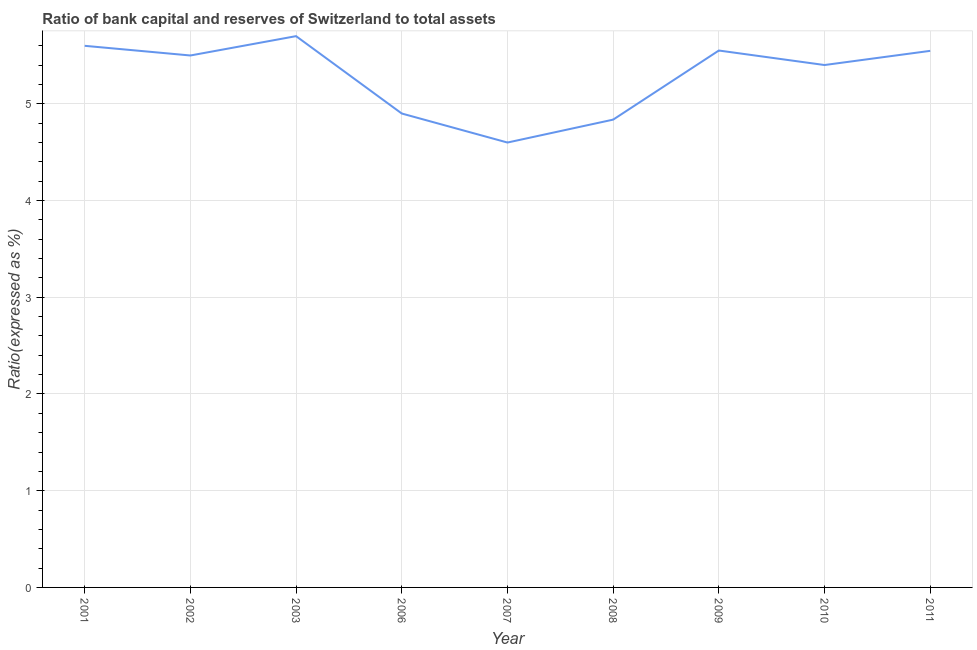Across all years, what is the maximum bank capital to assets ratio?
Provide a short and direct response. 5.7. In which year was the bank capital to assets ratio minimum?
Provide a short and direct response. 2007. What is the sum of the bank capital to assets ratio?
Provide a short and direct response. 47.64. What is the difference between the bank capital to assets ratio in 2002 and 2010?
Your response must be concise. 0.1. What is the average bank capital to assets ratio per year?
Your response must be concise. 5.29. What is the median bank capital to assets ratio?
Provide a short and direct response. 5.5. What is the ratio of the bank capital to assets ratio in 2002 to that in 2011?
Your response must be concise. 0.99. Is the bank capital to assets ratio in 2002 less than that in 2006?
Ensure brevity in your answer.  No. What is the difference between the highest and the second highest bank capital to assets ratio?
Give a very brief answer. 0.1. What is the difference between the highest and the lowest bank capital to assets ratio?
Ensure brevity in your answer.  1.1. Does the bank capital to assets ratio monotonically increase over the years?
Your answer should be compact. No. How many lines are there?
Keep it short and to the point. 1. Does the graph contain grids?
Ensure brevity in your answer.  Yes. What is the title of the graph?
Your response must be concise. Ratio of bank capital and reserves of Switzerland to total assets. What is the label or title of the X-axis?
Give a very brief answer. Year. What is the label or title of the Y-axis?
Provide a short and direct response. Ratio(expressed as %). What is the Ratio(expressed as %) in 2001?
Offer a very short reply. 5.6. What is the Ratio(expressed as %) of 2002?
Keep it short and to the point. 5.5. What is the Ratio(expressed as %) in 2003?
Give a very brief answer. 5.7. What is the Ratio(expressed as %) in 2006?
Ensure brevity in your answer.  4.9. What is the Ratio(expressed as %) of 2007?
Keep it short and to the point. 4.6. What is the Ratio(expressed as %) in 2008?
Provide a succinct answer. 4.84. What is the Ratio(expressed as %) of 2009?
Your response must be concise. 5.55. What is the Ratio(expressed as %) of 2010?
Provide a succinct answer. 5.4. What is the Ratio(expressed as %) in 2011?
Offer a very short reply. 5.55. What is the difference between the Ratio(expressed as %) in 2001 and 2002?
Your answer should be very brief. 0.1. What is the difference between the Ratio(expressed as %) in 2001 and 2008?
Your answer should be compact. 0.76. What is the difference between the Ratio(expressed as %) in 2001 and 2009?
Your answer should be compact. 0.05. What is the difference between the Ratio(expressed as %) in 2001 and 2010?
Make the answer very short. 0.2. What is the difference between the Ratio(expressed as %) in 2001 and 2011?
Make the answer very short. 0.05. What is the difference between the Ratio(expressed as %) in 2002 and 2003?
Your answer should be compact. -0.2. What is the difference between the Ratio(expressed as %) in 2002 and 2006?
Provide a succinct answer. 0.6. What is the difference between the Ratio(expressed as %) in 2002 and 2007?
Provide a short and direct response. 0.9. What is the difference between the Ratio(expressed as %) in 2002 and 2008?
Give a very brief answer. 0.66. What is the difference between the Ratio(expressed as %) in 2002 and 2009?
Offer a very short reply. -0.05. What is the difference between the Ratio(expressed as %) in 2002 and 2010?
Provide a short and direct response. 0.1. What is the difference between the Ratio(expressed as %) in 2002 and 2011?
Your answer should be compact. -0.05. What is the difference between the Ratio(expressed as %) in 2003 and 2006?
Your answer should be compact. 0.8. What is the difference between the Ratio(expressed as %) in 2003 and 2008?
Your response must be concise. 0.86. What is the difference between the Ratio(expressed as %) in 2003 and 2009?
Provide a short and direct response. 0.15. What is the difference between the Ratio(expressed as %) in 2003 and 2010?
Provide a short and direct response. 0.3. What is the difference between the Ratio(expressed as %) in 2003 and 2011?
Offer a very short reply. 0.15. What is the difference between the Ratio(expressed as %) in 2006 and 2007?
Keep it short and to the point. 0.3. What is the difference between the Ratio(expressed as %) in 2006 and 2008?
Make the answer very short. 0.06. What is the difference between the Ratio(expressed as %) in 2006 and 2009?
Offer a terse response. -0.65. What is the difference between the Ratio(expressed as %) in 2006 and 2010?
Your answer should be very brief. -0.5. What is the difference between the Ratio(expressed as %) in 2006 and 2011?
Give a very brief answer. -0.65. What is the difference between the Ratio(expressed as %) in 2007 and 2008?
Your response must be concise. -0.24. What is the difference between the Ratio(expressed as %) in 2007 and 2009?
Give a very brief answer. -0.95. What is the difference between the Ratio(expressed as %) in 2007 and 2010?
Make the answer very short. -0.8. What is the difference between the Ratio(expressed as %) in 2007 and 2011?
Provide a succinct answer. -0.95. What is the difference between the Ratio(expressed as %) in 2008 and 2009?
Offer a very short reply. -0.71. What is the difference between the Ratio(expressed as %) in 2008 and 2010?
Ensure brevity in your answer.  -0.56. What is the difference between the Ratio(expressed as %) in 2008 and 2011?
Keep it short and to the point. -0.71. What is the difference between the Ratio(expressed as %) in 2009 and 2010?
Your answer should be very brief. 0.15. What is the difference between the Ratio(expressed as %) in 2009 and 2011?
Provide a succinct answer. 0. What is the difference between the Ratio(expressed as %) in 2010 and 2011?
Your response must be concise. -0.15. What is the ratio of the Ratio(expressed as %) in 2001 to that in 2006?
Your answer should be compact. 1.14. What is the ratio of the Ratio(expressed as %) in 2001 to that in 2007?
Your response must be concise. 1.22. What is the ratio of the Ratio(expressed as %) in 2001 to that in 2008?
Provide a short and direct response. 1.16. What is the ratio of the Ratio(expressed as %) in 2001 to that in 2009?
Offer a very short reply. 1.01. What is the ratio of the Ratio(expressed as %) in 2002 to that in 2003?
Offer a very short reply. 0.96. What is the ratio of the Ratio(expressed as %) in 2002 to that in 2006?
Your answer should be very brief. 1.12. What is the ratio of the Ratio(expressed as %) in 2002 to that in 2007?
Your answer should be compact. 1.2. What is the ratio of the Ratio(expressed as %) in 2002 to that in 2008?
Your answer should be compact. 1.14. What is the ratio of the Ratio(expressed as %) in 2002 to that in 2011?
Your answer should be very brief. 0.99. What is the ratio of the Ratio(expressed as %) in 2003 to that in 2006?
Your response must be concise. 1.16. What is the ratio of the Ratio(expressed as %) in 2003 to that in 2007?
Ensure brevity in your answer.  1.24. What is the ratio of the Ratio(expressed as %) in 2003 to that in 2008?
Your response must be concise. 1.18. What is the ratio of the Ratio(expressed as %) in 2003 to that in 2009?
Your answer should be compact. 1.03. What is the ratio of the Ratio(expressed as %) in 2003 to that in 2010?
Offer a very short reply. 1.05. What is the ratio of the Ratio(expressed as %) in 2003 to that in 2011?
Your answer should be compact. 1.03. What is the ratio of the Ratio(expressed as %) in 2006 to that in 2007?
Your answer should be compact. 1.06. What is the ratio of the Ratio(expressed as %) in 2006 to that in 2009?
Ensure brevity in your answer.  0.88. What is the ratio of the Ratio(expressed as %) in 2006 to that in 2010?
Make the answer very short. 0.91. What is the ratio of the Ratio(expressed as %) in 2006 to that in 2011?
Your answer should be compact. 0.88. What is the ratio of the Ratio(expressed as %) in 2007 to that in 2008?
Give a very brief answer. 0.95. What is the ratio of the Ratio(expressed as %) in 2007 to that in 2009?
Ensure brevity in your answer.  0.83. What is the ratio of the Ratio(expressed as %) in 2007 to that in 2010?
Your answer should be very brief. 0.85. What is the ratio of the Ratio(expressed as %) in 2007 to that in 2011?
Offer a terse response. 0.83. What is the ratio of the Ratio(expressed as %) in 2008 to that in 2009?
Keep it short and to the point. 0.87. What is the ratio of the Ratio(expressed as %) in 2008 to that in 2010?
Offer a very short reply. 0.9. What is the ratio of the Ratio(expressed as %) in 2008 to that in 2011?
Your answer should be compact. 0.87. What is the ratio of the Ratio(expressed as %) in 2009 to that in 2010?
Your answer should be very brief. 1.03. What is the ratio of the Ratio(expressed as %) in 2009 to that in 2011?
Provide a short and direct response. 1. What is the ratio of the Ratio(expressed as %) in 2010 to that in 2011?
Your answer should be very brief. 0.97. 